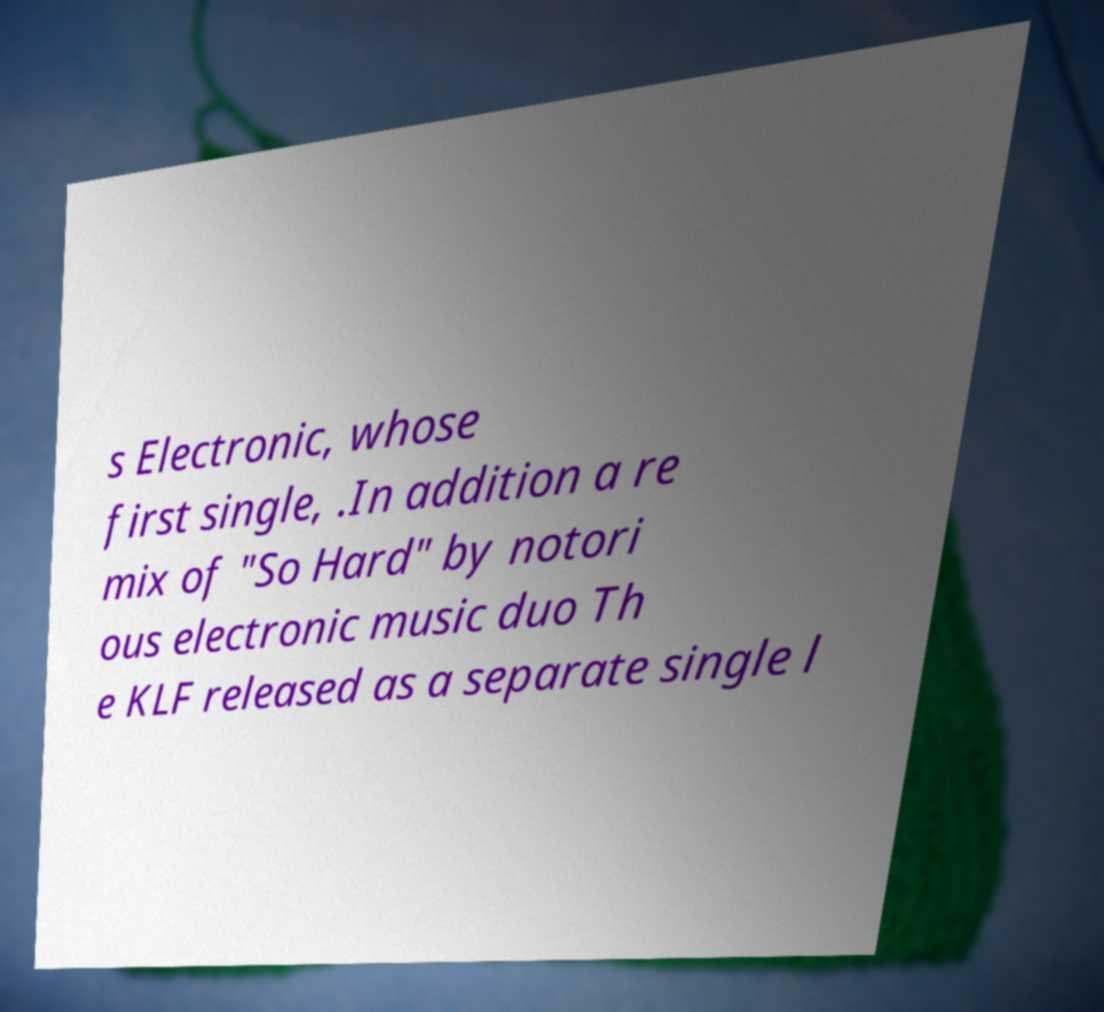Can you read and provide the text displayed in the image?This photo seems to have some interesting text. Can you extract and type it out for me? s Electronic, whose first single, .In addition a re mix of "So Hard" by notori ous electronic music duo Th e KLF released as a separate single l 